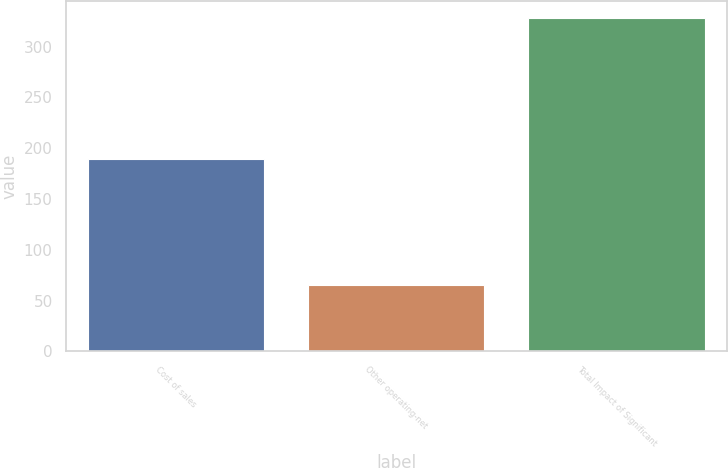Convert chart. <chart><loc_0><loc_0><loc_500><loc_500><bar_chart><fcel>Cost of sales<fcel>Other operating-net<fcel>Total Impact of Significant<nl><fcel>189<fcel>65<fcel>328<nl></chart> 